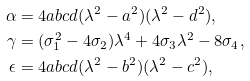Convert formula to latex. <formula><loc_0><loc_0><loc_500><loc_500>\alpha & = 4 a b c d ( \lambda ^ { 2 } - a ^ { 2 } ) ( \lambda ^ { 2 } - d ^ { 2 } ) , \\ \gamma & = ( \sigma _ { 1 } ^ { 2 } - 4 \sigma _ { 2 } ) \lambda ^ { 4 } + 4 \sigma _ { 3 } \lambda ^ { 2 } - 8 \sigma _ { 4 } , \\ \epsilon & = 4 a b c d ( \lambda ^ { 2 } - b ^ { 2 } ) ( \lambda ^ { 2 } - c ^ { 2 } ) ,</formula> 